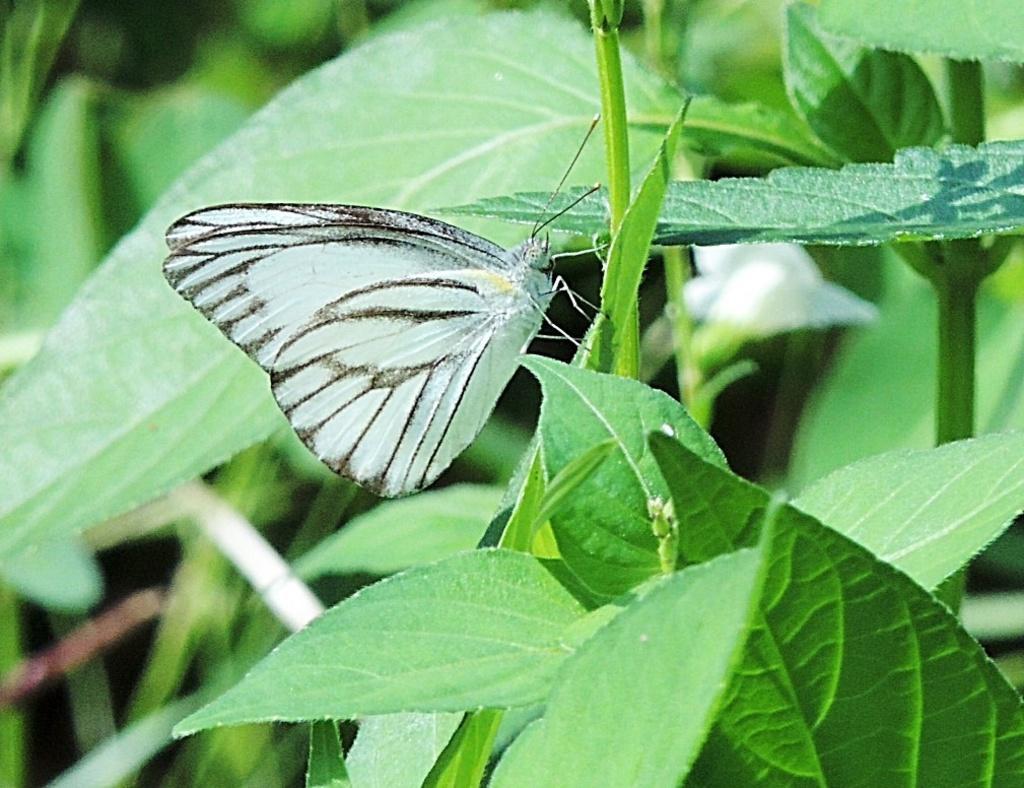Describe this image in one or two sentences. In this image we can see a butterfly which is on stem of a plant and in the background of the image there is a flower which is in white color and we can see some leaves. 